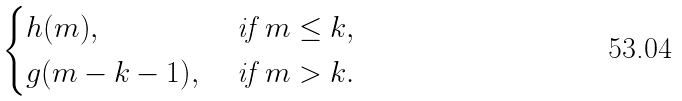<formula> <loc_0><loc_0><loc_500><loc_500>\begin{cases} h ( m ) , \ & \text {if} \ m \leq k , \\ g ( m - k - 1 ) , \ & \text {if} \ m > k . \end{cases}</formula> 